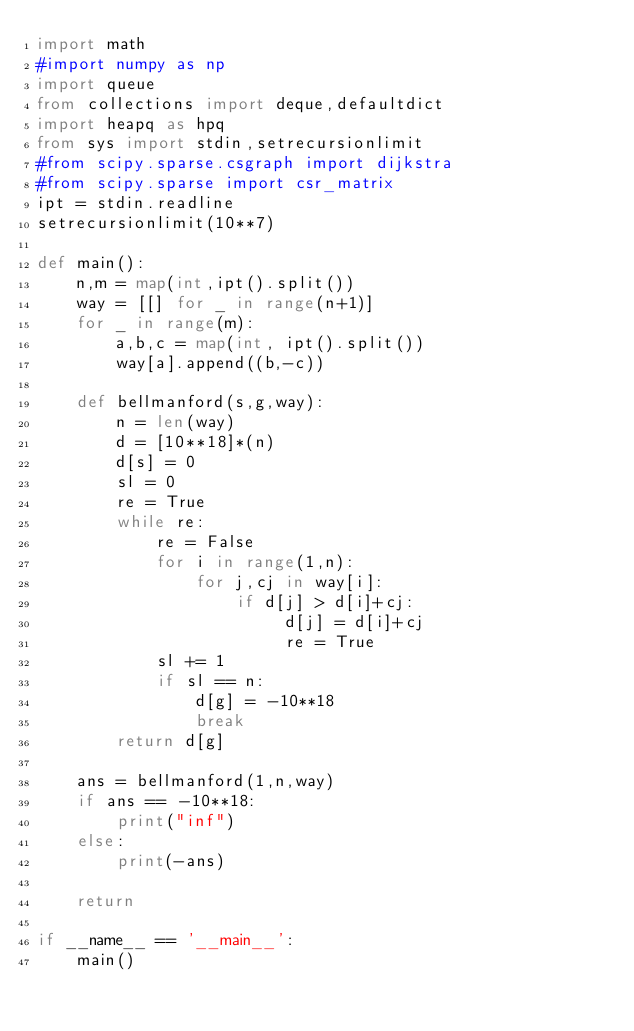<code> <loc_0><loc_0><loc_500><loc_500><_Python_>import math
#import numpy as np
import queue
from collections import deque,defaultdict
import heapq as hpq
from sys import stdin,setrecursionlimit
#from scipy.sparse.csgraph import dijkstra
#from scipy.sparse import csr_matrix
ipt = stdin.readline
setrecursionlimit(10**7)

def main():
    n,m = map(int,ipt().split())
    way = [[] for _ in range(n+1)]
    for _ in range(m):
        a,b,c = map(int, ipt().split())
        way[a].append((b,-c))

    def bellmanford(s,g,way):
        n = len(way)
        d = [10**18]*(n)
        d[s] = 0
        sl = 0
        re = True
        while re:
            re = False
            for i in range(1,n):
                for j,cj in way[i]:
                    if d[j] > d[i]+cj:
                         d[j] = d[i]+cj
                         re = True
            sl += 1
            if sl == n:
                d[g] = -10**18
                break
        return d[g]

    ans = bellmanford(1,n,way)
    if ans == -10**18:
        print("inf")
    else:
        print(-ans)

    return

if __name__ == '__main__':
    main()
</code> 